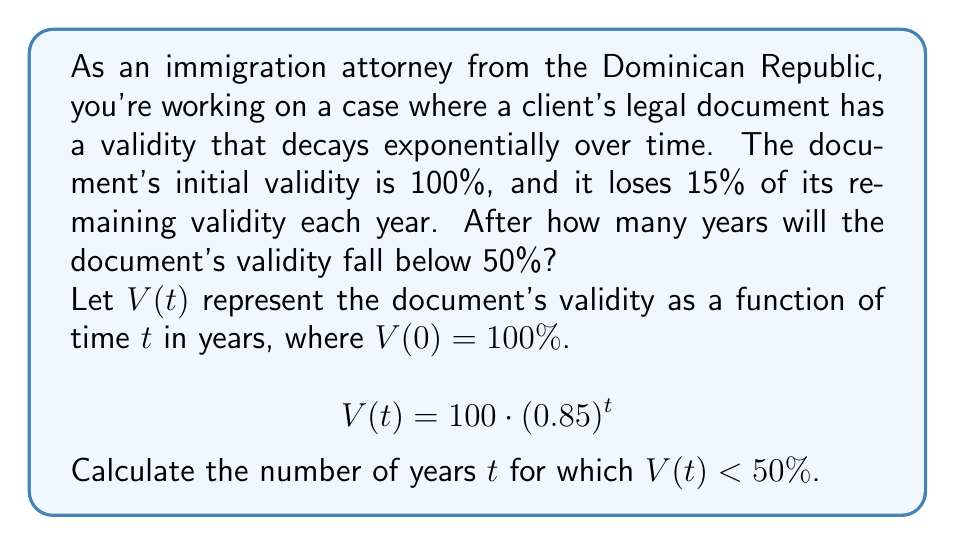Solve this math problem. To solve this problem, we need to use the properties of exponential functions and logarithms. Let's approach this step-by-step:

1) We start with the equation:
   $$V(t) = 100 \cdot (0.85)^t$$

2) We want to find when this becomes less than 50%:
   $$100 \cdot (0.85)^t < 50$$

3) Divide both sides by 100:
   $$(0.85)^t < 0.5$$

4) To solve for $t$, we need to take the logarithm of both sides. We can use any base for the logarithm, but let's use the natural log (ln) for simplicity:
   $$\ln((0.85)^t) < \ln(0.5)$$

5) Using the logarithm property $\ln(a^b) = b\ln(a)$:
   $$t \cdot \ln(0.85) < \ln(0.5)$$

6) Divide both sides by $\ln(0.85)$ (note that $\ln(0.85)$ is negative, so the inequality sign flips):
   $$t > \frac{\ln(0.5)}{\ln(0.85)}$$

7) Calculate this value:
   $$t > \frac{\ln(0.5)}{\ln(0.85)} \approx 4.2735$$

8) Since we're looking for the number of whole years, we need to round up to the next integer.
Answer: The document's validity will fall below 50% after 5 years. 